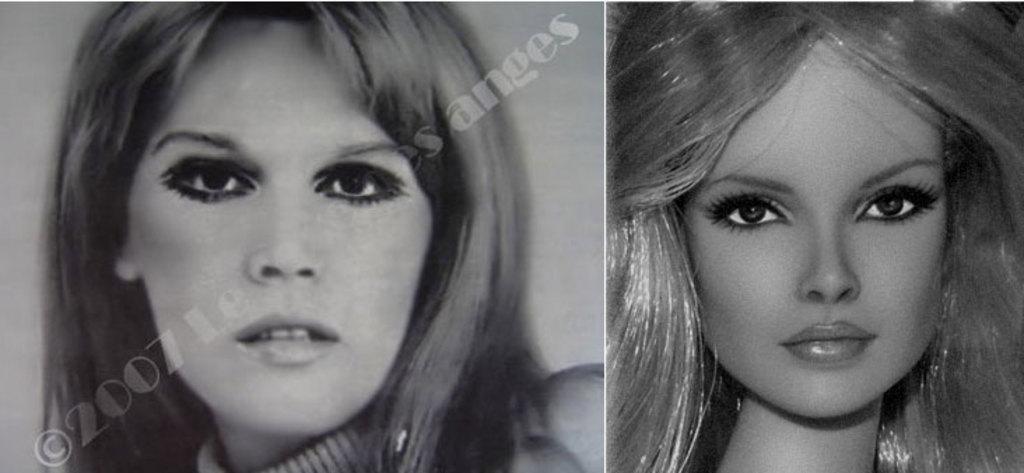Please provide a concise description of this image. In this picture I can see it looks like a photo collage, on the left side there is an image of a woman, in the middle there is the watermark. On the right side there is an image of a doll. 